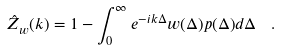<formula> <loc_0><loc_0><loc_500><loc_500>\hat { Z } _ { w } ( k ) = 1 - \int _ { 0 } ^ { \infty } e ^ { - i k \Delta } w ( \Delta ) p ( \Delta ) d \Delta \ \ .</formula> 